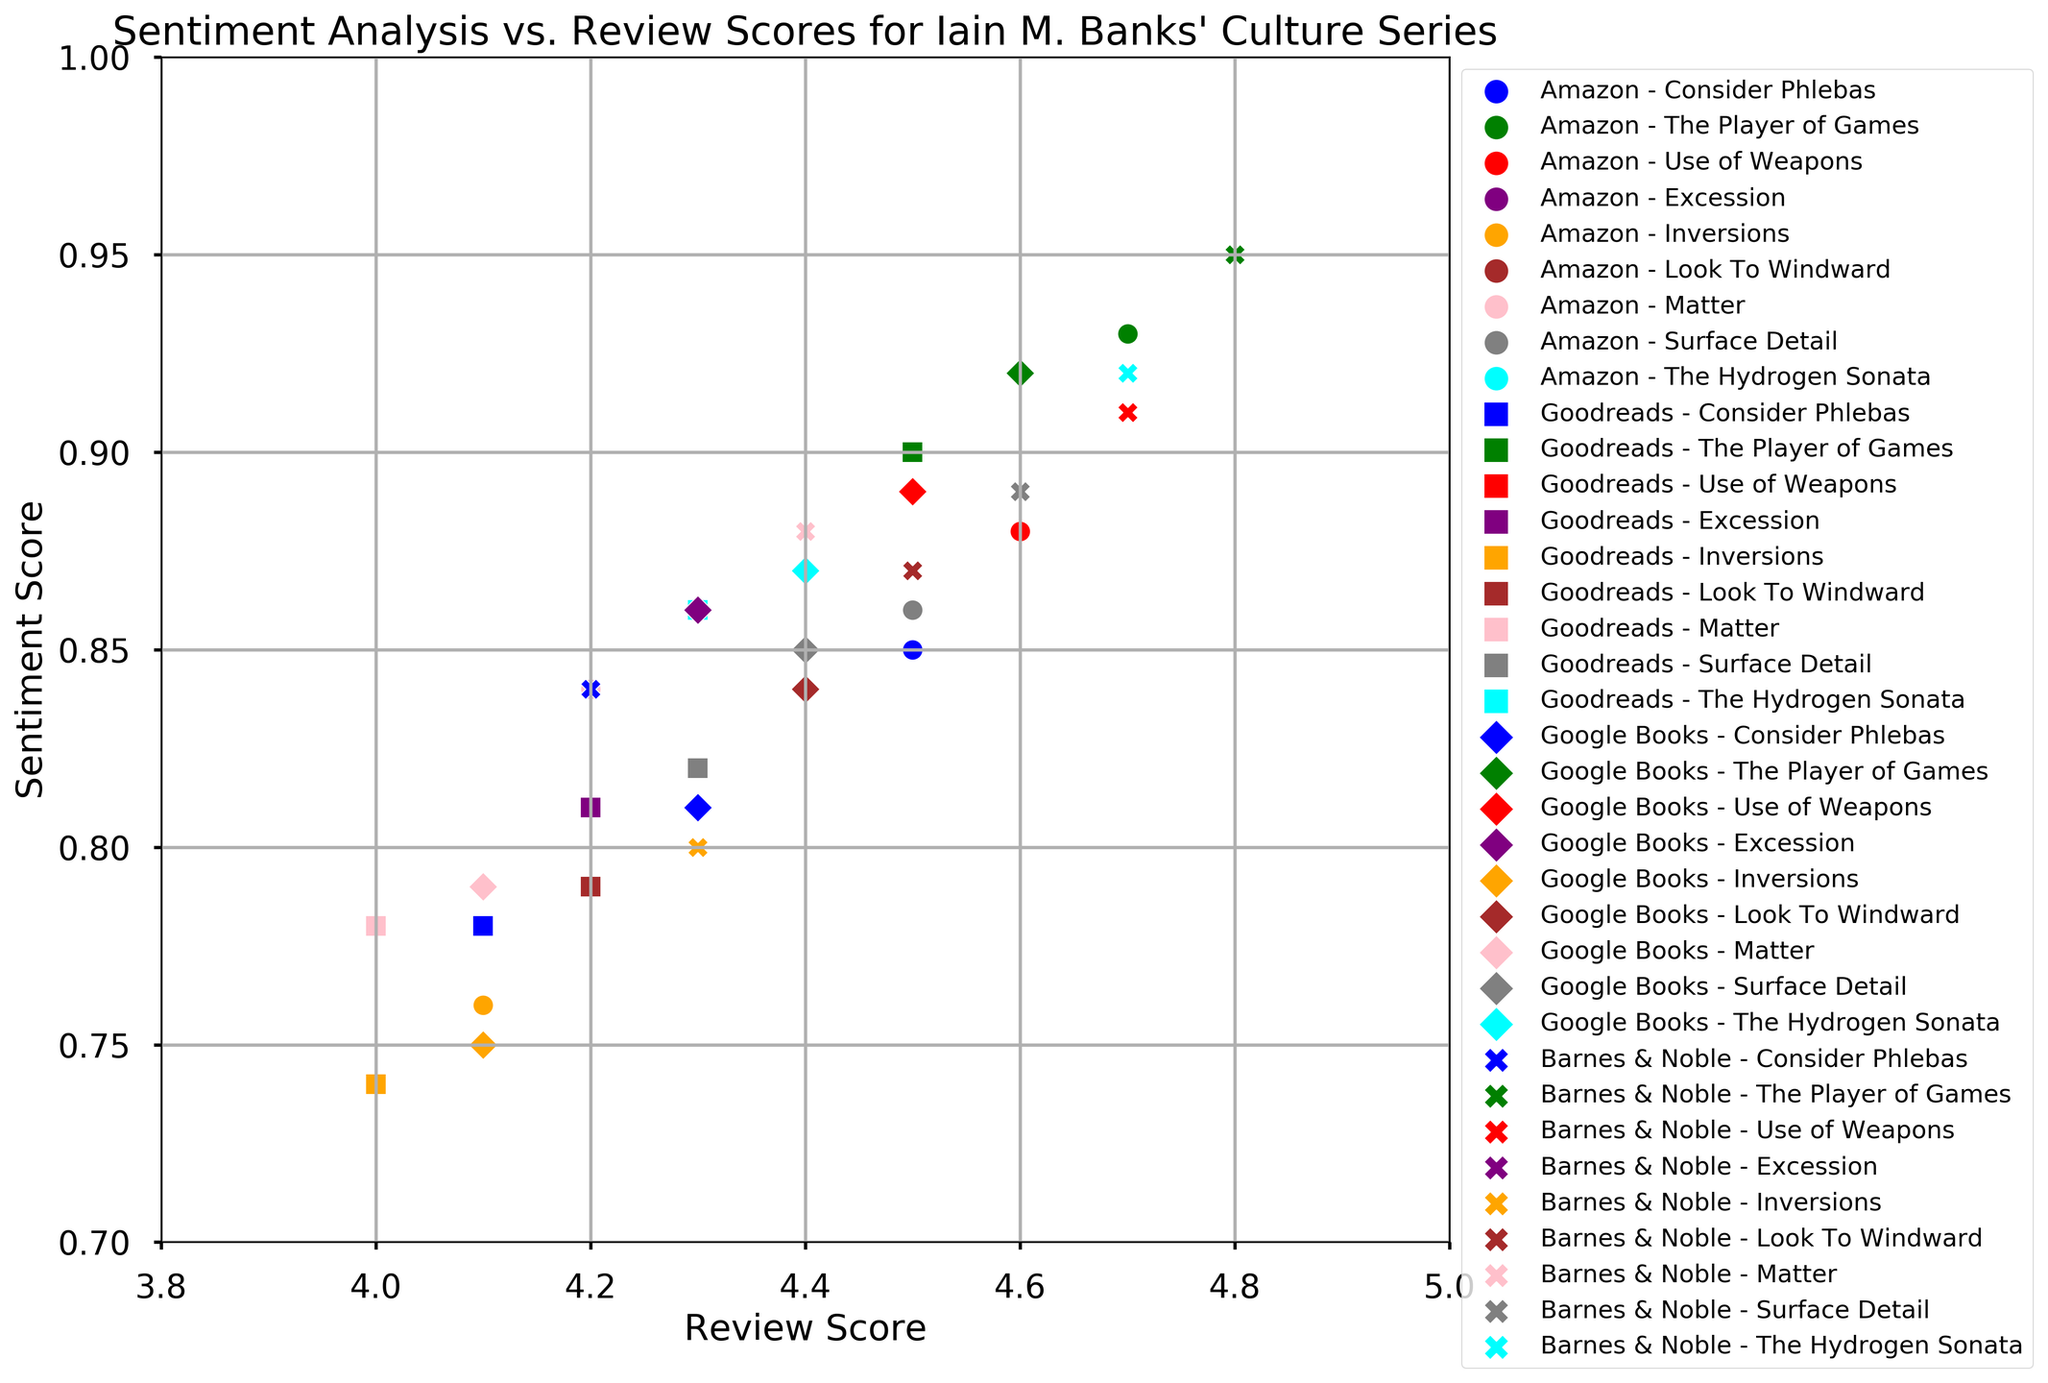Which book has the highest sentiment score on Barnes & Noble? By looking at the scatter plot, we need to find the book with the highest dot on the y-axis for Barnes & Noble which is represented by X markers.
Answer: The Player of Games Between Amazon and Goodreads, which platform gives a higher review score for "Consider Phlebas"? First, identify the dots for "Consider Phlebas" on Amazon and Goodreads by their markers and colors. Then, compare their positions on the x-axis.
Answer: Amazon What is the difference in sentiment score between "Use of Weapons" on Google Books and "Use of Weapons" on Amazon? Locate the markers for "Use of Weapons" on both Google Books and Amazon. Note their y-axis positions and subtract the Amazon sentiment score from the Google Books sentiment score.
Answer: 0.01 Which platform has the most consistent sentiment scores for all books? Evaluate the spread of the sentiment scores for each platform. The platform with the least range in y-axis positions (uniform vertical spread of its markers) is the most consistent.
Answer: Barnes & Noble What is the average review score of "The Hydrogen Sonata" across all platforms? Sum the review scores of "The Hydrogen Sonata" from all platforms and divide by the number of platforms (Amazon, Goodreads, Google Books, Barnes & Noble). (4.5 + 4.3 + 4.4 + 4.7)/4
Answer: 4.475 Which book shows the largest variation in review scores across different platforms? For each book, calculate the difference between the highest and lowest review scores across platforms (x-axis values), and identify the book with the largest variation.
Answer: Inversions How do the sentiment scores of "Excession" compare between Goodreads and Barnes & Noble? Find the sentiment scores of "Excession" on Goodreads and Barnes & Noble by identifying the respective markers for this book and comparing their y-axis values.
Answer: Barnes & Noble is higher Which book on Google Books has the closest sentiment score to 0.90? Look for the markers on the scatter plot representing books from Google Books, and identify which marker is closest to the y-axis value of 0.90.
Answer: Use of Weapons Among the platforms, which one gives "Matter" the lowest review score? Identify the markers for "Matter" across all platforms and find the one with the lowest x-axis value.
Answer: Goodreads 